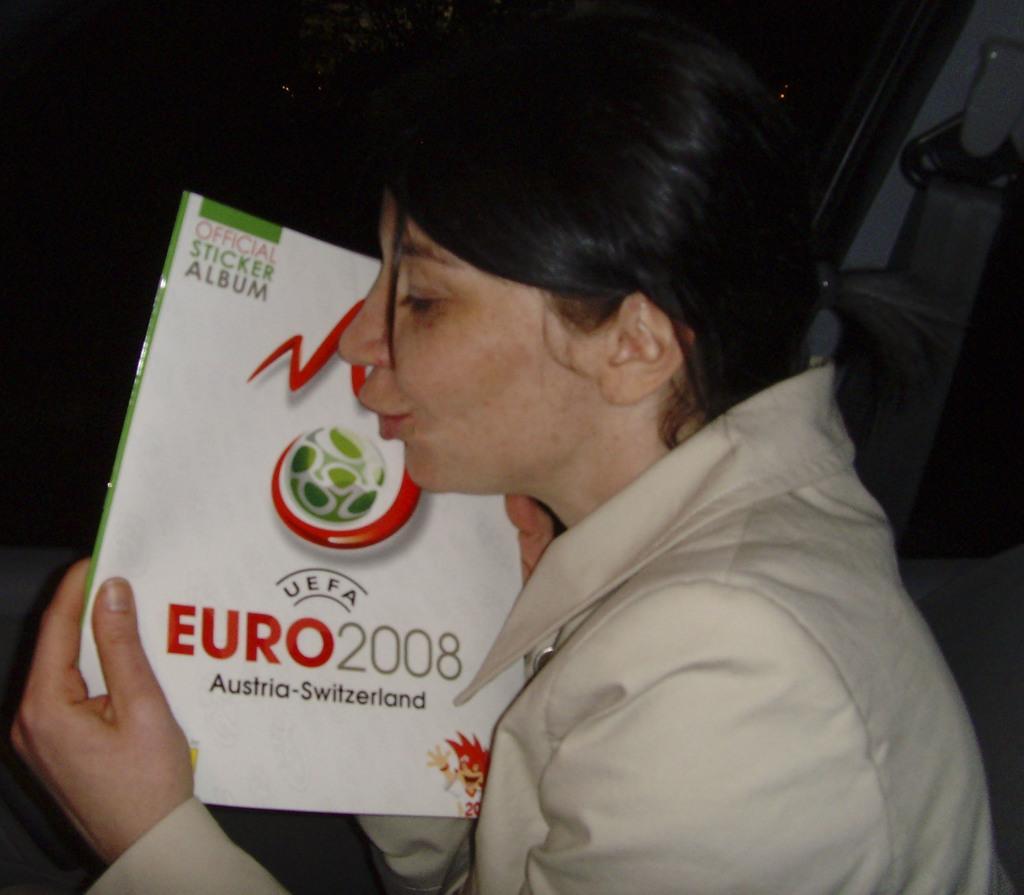Describe this image in one or two sentences. In this picture we can see a woman wearing a blazer and holding a book with her hands and in the background we can see some objects and it is dark. 